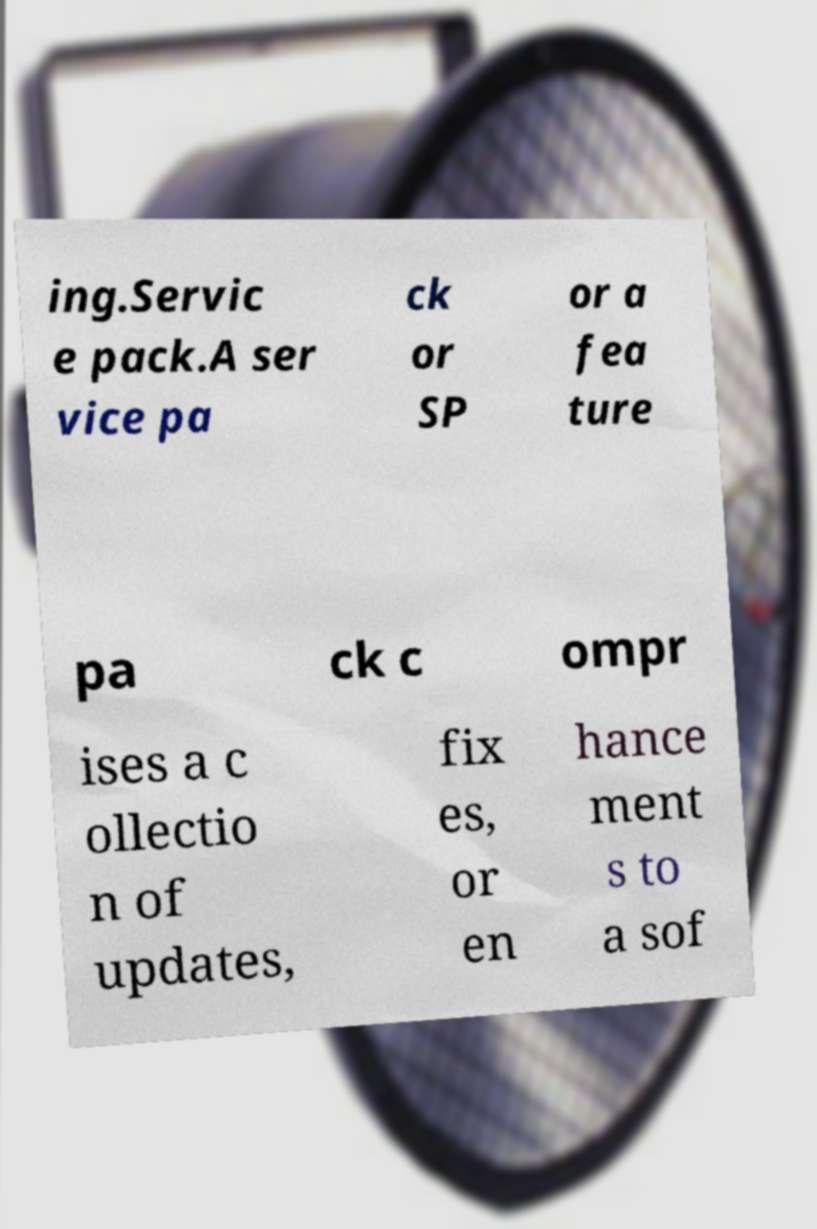Can you read and provide the text displayed in the image?This photo seems to have some interesting text. Can you extract and type it out for me? ing.Servic e pack.A ser vice pa ck or SP or a fea ture pa ck c ompr ises a c ollectio n of updates, fix es, or en hance ment s to a sof 